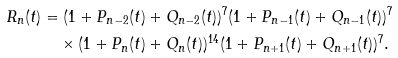<formula> <loc_0><loc_0><loc_500><loc_500>R _ { n } ( t ) & = ( 1 + P _ { n - 2 } ( t ) + Q _ { n - 2 } ( t ) ) ^ { 7 } ( 1 + P _ { n - 1 } ( t ) + Q _ { n - 1 } ( t ) ) ^ { 7 } \\ & \quad \times ( 1 + P _ { n } ( t ) + Q _ { n } ( t ) ) ^ { 1 4 } ( 1 + P _ { n + 1 } ( t ) + Q _ { n + 1 } ( t ) ) ^ { 7 } .</formula> 